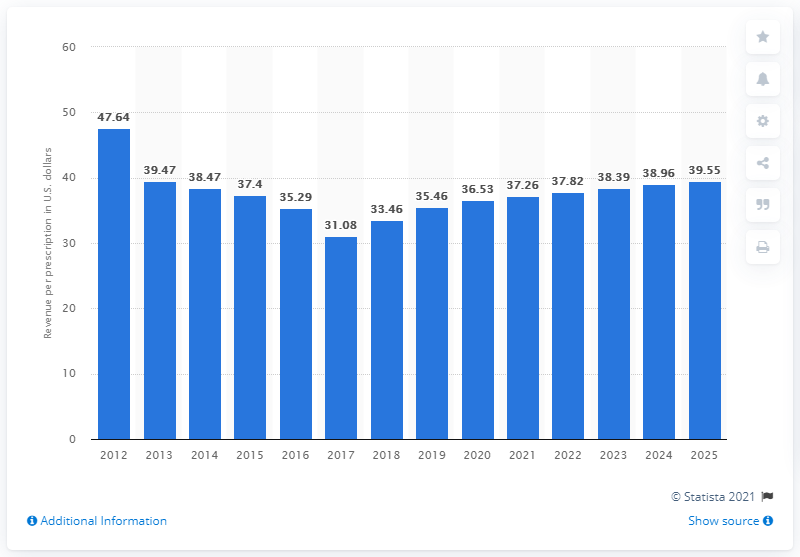Give some essential details in this illustration. In 2025, the revenue per retail prescription at CVS Caremark came to an end. The estimated cost of a retail prescription in 2018 is $33.46. It is known that a retail prescription was sold at CVS Caremark in the year 2012. 